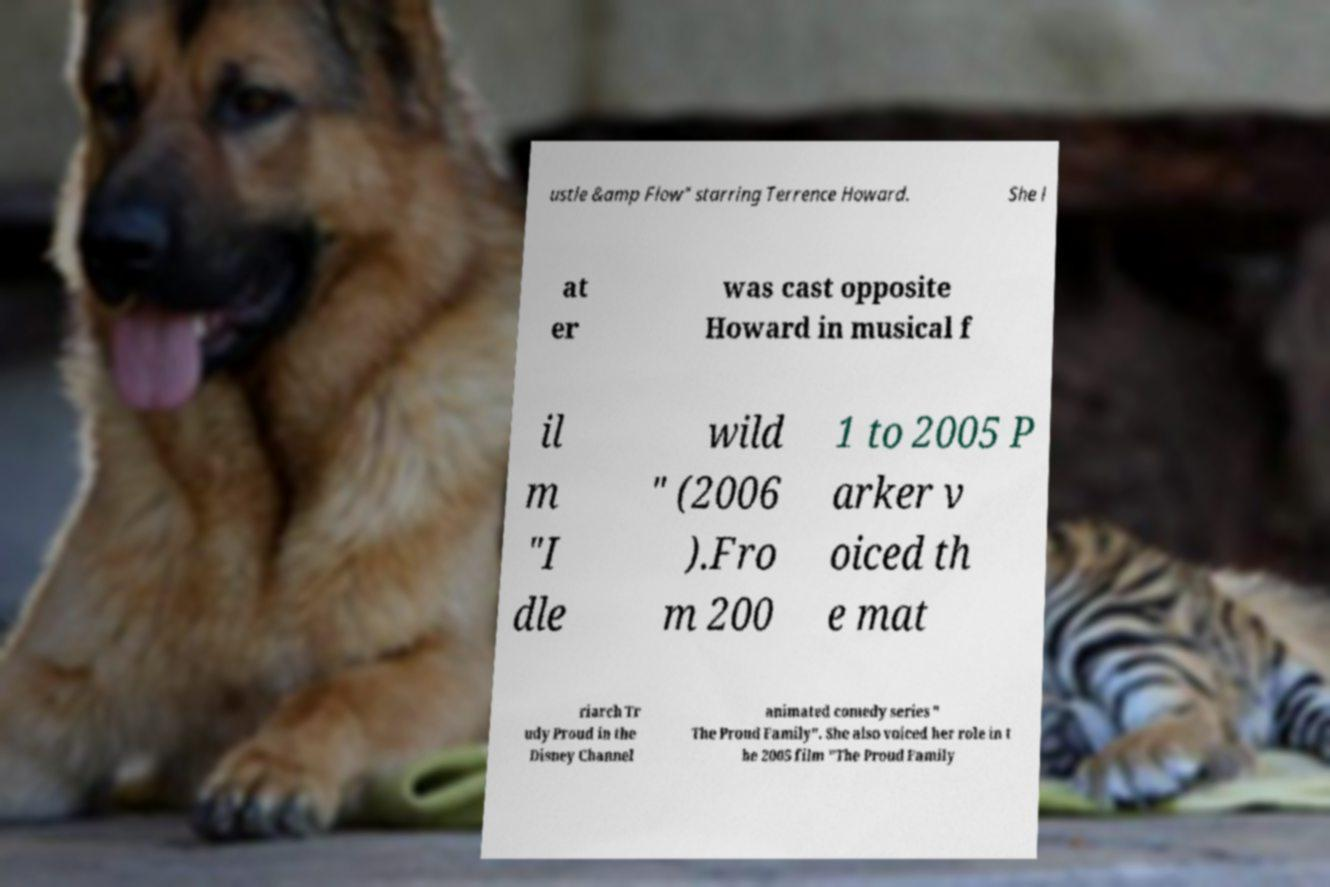Could you assist in decoding the text presented in this image and type it out clearly? ustle &amp Flow" starring Terrence Howard. She l at er was cast opposite Howard in musical f il m "I dle wild " (2006 ).Fro m 200 1 to 2005 P arker v oiced th e mat riarch Tr udy Proud in the Disney Channel animated comedy series " The Proud Family". She also voiced her role in t he 2005 film "The Proud Family 